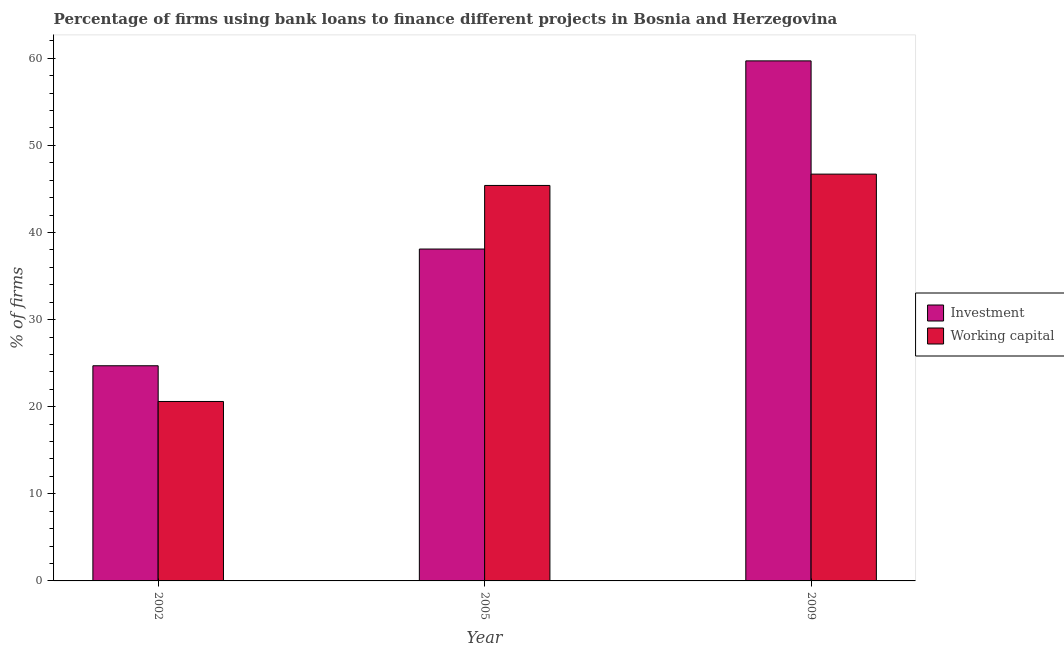Are the number of bars per tick equal to the number of legend labels?
Give a very brief answer. Yes. Are the number of bars on each tick of the X-axis equal?
Your answer should be very brief. Yes. How many bars are there on the 1st tick from the right?
Your answer should be compact. 2. In how many cases, is the number of bars for a given year not equal to the number of legend labels?
Give a very brief answer. 0. What is the percentage of firms using banks to finance investment in 2005?
Provide a succinct answer. 38.1. Across all years, what is the maximum percentage of firms using banks to finance working capital?
Ensure brevity in your answer.  46.7. Across all years, what is the minimum percentage of firms using banks to finance working capital?
Your answer should be compact. 20.6. What is the total percentage of firms using banks to finance investment in the graph?
Offer a very short reply. 122.5. What is the difference between the percentage of firms using banks to finance investment in 2002 and that in 2005?
Make the answer very short. -13.4. What is the difference between the percentage of firms using banks to finance working capital in 2009 and the percentage of firms using banks to finance investment in 2002?
Provide a short and direct response. 26.1. What is the average percentage of firms using banks to finance working capital per year?
Your response must be concise. 37.57. What is the ratio of the percentage of firms using banks to finance investment in 2002 to that in 2005?
Provide a succinct answer. 0.65. Is the difference between the percentage of firms using banks to finance working capital in 2002 and 2005 greater than the difference between the percentage of firms using banks to finance investment in 2002 and 2005?
Keep it short and to the point. No. What is the difference between the highest and the second highest percentage of firms using banks to finance investment?
Offer a terse response. 21.6. Is the sum of the percentage of firms using banks to finance working capital in 2002 and 2009 greater than the maximum percentage of firms using banks to finance investment across all years?
Provide a short and direct response. Yes. What does the 1st bar from the left in 2009 represents?
Provide a succinct answer. Investment. What does the 1st bar from the right in 2005 represents?
Provide a succinct answer. Working capital. How many bars are there?
Ensure brevity in your answer.  6. Are all the bars in the graph horizontal?
Offer a very short reply. No. How many years are there in the graph?
Give a very brief answer. 3. What is the difference between two consecutive major ticks on the Y-axis?
Your answer should be compact. 10. Are the values on the major ticks of Y-axis written in scientific E-notation?
Keep it short and to the point. No. How many legend labels are there?
Make the answer very short. 2. How are the legend labels stacked?
Your answer should be very brief. Vertical. What is the title of the graph?
Your answer should be compact. Percentage of firms using bank loans to finance different projects in Bosnia and Herzegovina. What is the label or title of the X-axis?
Your answer should be very brief. Year. What is the label or title of the Y-axis?
Your answer should be compact. % of firms. What is the % of firms in Investment in 2002?
Offer a terse response. 24.7. What is the % of firms of Working capital in 2002?
Offer a very short reply. 20.6. What is the % of firms of Investment in 2005?
Offer a terse response. 38.1. What is the % of firms of Working capital in 2005?
Give a very brief answer. 45.4. What is the % of firms in Investment in 2009?
Your answer should be very brief. 59.7. What is the % of firms of Working capital in 2009?
Make the answer very short. 46.7. Across all years, what is the maximum % of firms in Investment?
Ensure brevity in your answer.  59.7. Across all years, what is the maximum % of firms in Working capital?
Your answer should be compact. 46.7. Across all years, what is the minimum % of firms in Investment?
Your answer should be very brief. 24.7. Across all years, what is the minimum % of firms of Working capital?
Keep it short and to the point. 20.6. What is the total % of firms of Investment in the graph?
Keep it short and to the point. 122.5. What is the total % of firms of Working capital in the graph?
Your answer should be very brief. 112.7. What is the difference between the % of firms of Investment in 2002 and that in 2005?
Give a very brief answer. -13.4. What is the difference between the % of firms of Working capital in 2002 and that in 2005?
Make the answer very short. -24.8. What is the difference between the % of firms in Investment in 2002 and that in 2009?
Provide a succinct answer. -35. What is the difference between the % of firms of Working capital in 2002 and that in 2009?
Offer a terse response. -26.1. What is the difference between the % of firms in Investment in 2005 and that in 2009?
Offer a terse response. -21.6. What is the difference between the % of firms of Working capital in 2005 and that in 2009?
Give a very brief answer. -1.3. What is the difference between the % of firms of Investment in 2002 and the % of firms of Working capital in 2005?
Provide a succinct answer. -20.7. What is the difference between the % of firms of Investment in 2002 and the % of firms of Working capital in 2009?
Give a very brief answer. -22. What is the average % of firms in Investment per year?
Provide a succinct answer. 40.83. What is the average % of firms in Working capital per year?
Offer a terse response. 37.57. In the year 2002, what is the difference between the % of firms in Investment and % of firms in Working capital?
Ensure brevity in your answer.  4.1. What is the ratio of the % of firms in Investment in 2002 to that in 2005?
Keep it short and to the point. 0.65. What is the ratio of the % of firms of Working capital in 2002 to that in 2005?
Give a very brief answer. 0.45. What is the ratio of the % of firms of Investment in 2002 to that in 2009?
Your response must be concise. 0.41. What is the ratio of the % of firms of Working capital in 2002 to that in 2009?
Your response must be concise. 0.44. What is the ratio of the % of firms in Investment in 2005 to that in 2009?
Your answer should be very brief. 0.64. What is the ratio of the % of firms of Working capital in 2005 to that in 2009?
Offer a very short reply. 0.97. What is the difference between the highest and the second highest % of firms in Investment?
Provide a succinct answer. 21.6. What is the difference between the highest and the lowest % of firms of Working capital?
Your response must be concise. 26.1. 